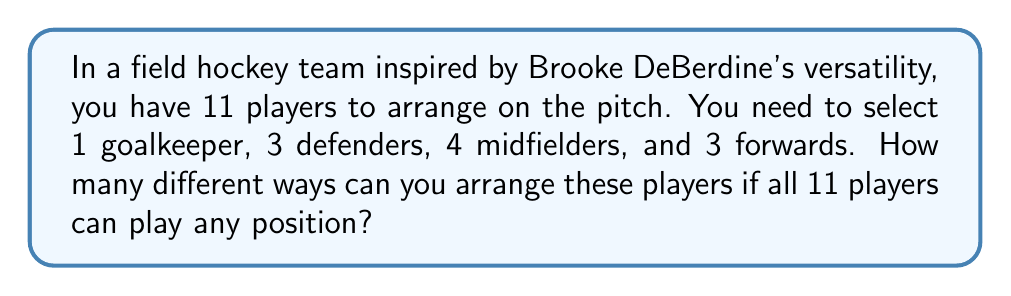Could you help me with this problem? Let's approach this step-by-step using the multiplication principle of counting:

1) First, we need to choose 1 goalkeeper out of 11 players:
   $${11 \choose 1} = 11$$

2) After selecting the goalkeeper, we have 10 players left. From these, we need to choose 3 defenders:
   $${10 \choose 3} = 120$$

3) We now have 7 players left, from which we need to select 4 midfielders:
   $${7 \choose 4} = 35$$

4) Finally, we have 3 players left for the 3 forward positions. There's only one way to do this:
   $${3 \choose 3} = 1$$

5) By the multiplication principle, the total number of ways to arrange the players is the product of these individual choices:

   $$11 \times 120 \times 35 \times 1 = 46,200$$

Therefore, there are 46,200 different ways to arrange the players in these positions.
Answer: 46,200 